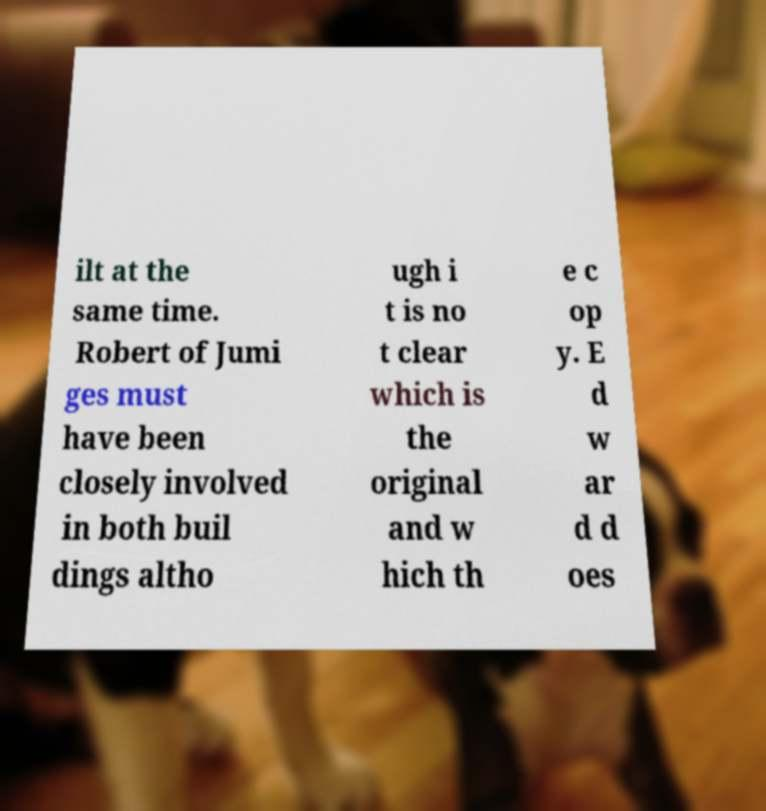Please read and relay the text visible in this image. What does it say? ilt at the same time. Robert of Jumi ges must have been closely involved in both buil dings altho ugh i t is no t clear which is the original and w hich th e c op y. E d w ar d d oes 